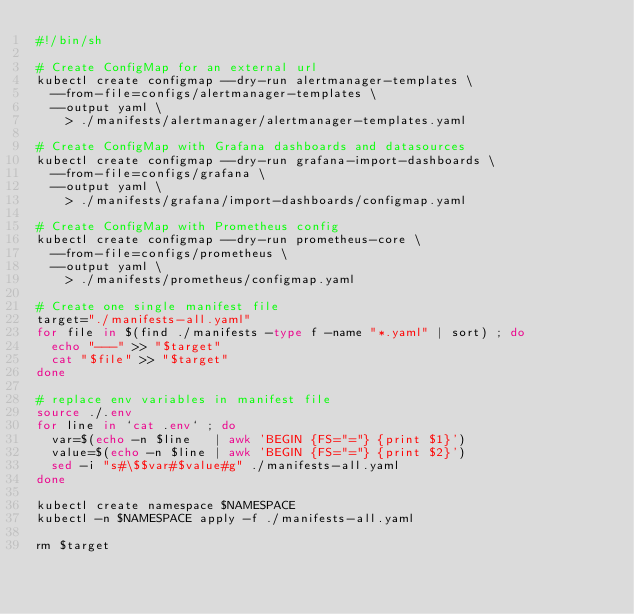Convert code to text. <code><loc_0><loc_0><loc_500><loc_500><_Bash_>#!/bin/sh

# Create ConfigMap for an external url
kubectl create configmap --dry-run alertmanager-templates \
  --from-file=configs/alertmanager-templates \
  --output yaml \
    > ./manifests/alertmanager/alertmanager-templates.yaml

# Create ConfigMap with Grafana dashboards and datasources
kubectl create configmap --dry-run grafana-import-dashboards \
  --from-file=configs/grafana \
  --output yaml \
    > ./manifests/grafana/import-dashboards/configmap.yaml

# Create ConfigMap with Prometheus config
kubectl create configmap --dry-run prometheus-core \
  --from-file=configs/prometheus \
  --output yaml \
    > ./manifests/prometheus/configmap.yaml

# Create one single manifest file
target="./manifests-all.yaml"
for file in $(find ./manifests -type f -name "*.yaml" | sort) ; do
  echo "---" >> "$target"
  cat "$file" >> "$target"
done

# replace env variables in manifest file
source ./.env
for line in `cat .env` ; do
  var=$(echo -n $line   | awk 'BEGIN {FS="="} {print $1}')
  value=$(echo -n $line | awk 'BEGIN {FS="="} {print $2}')
  sed -i "s#\$$var#$value#g" ./manifests-all.yaml
done

kubectl create namespace $NAMESPACE
kubectl -n $NAMESPACE apply -f ./manifests-all.yaml

rm $target
</code> 